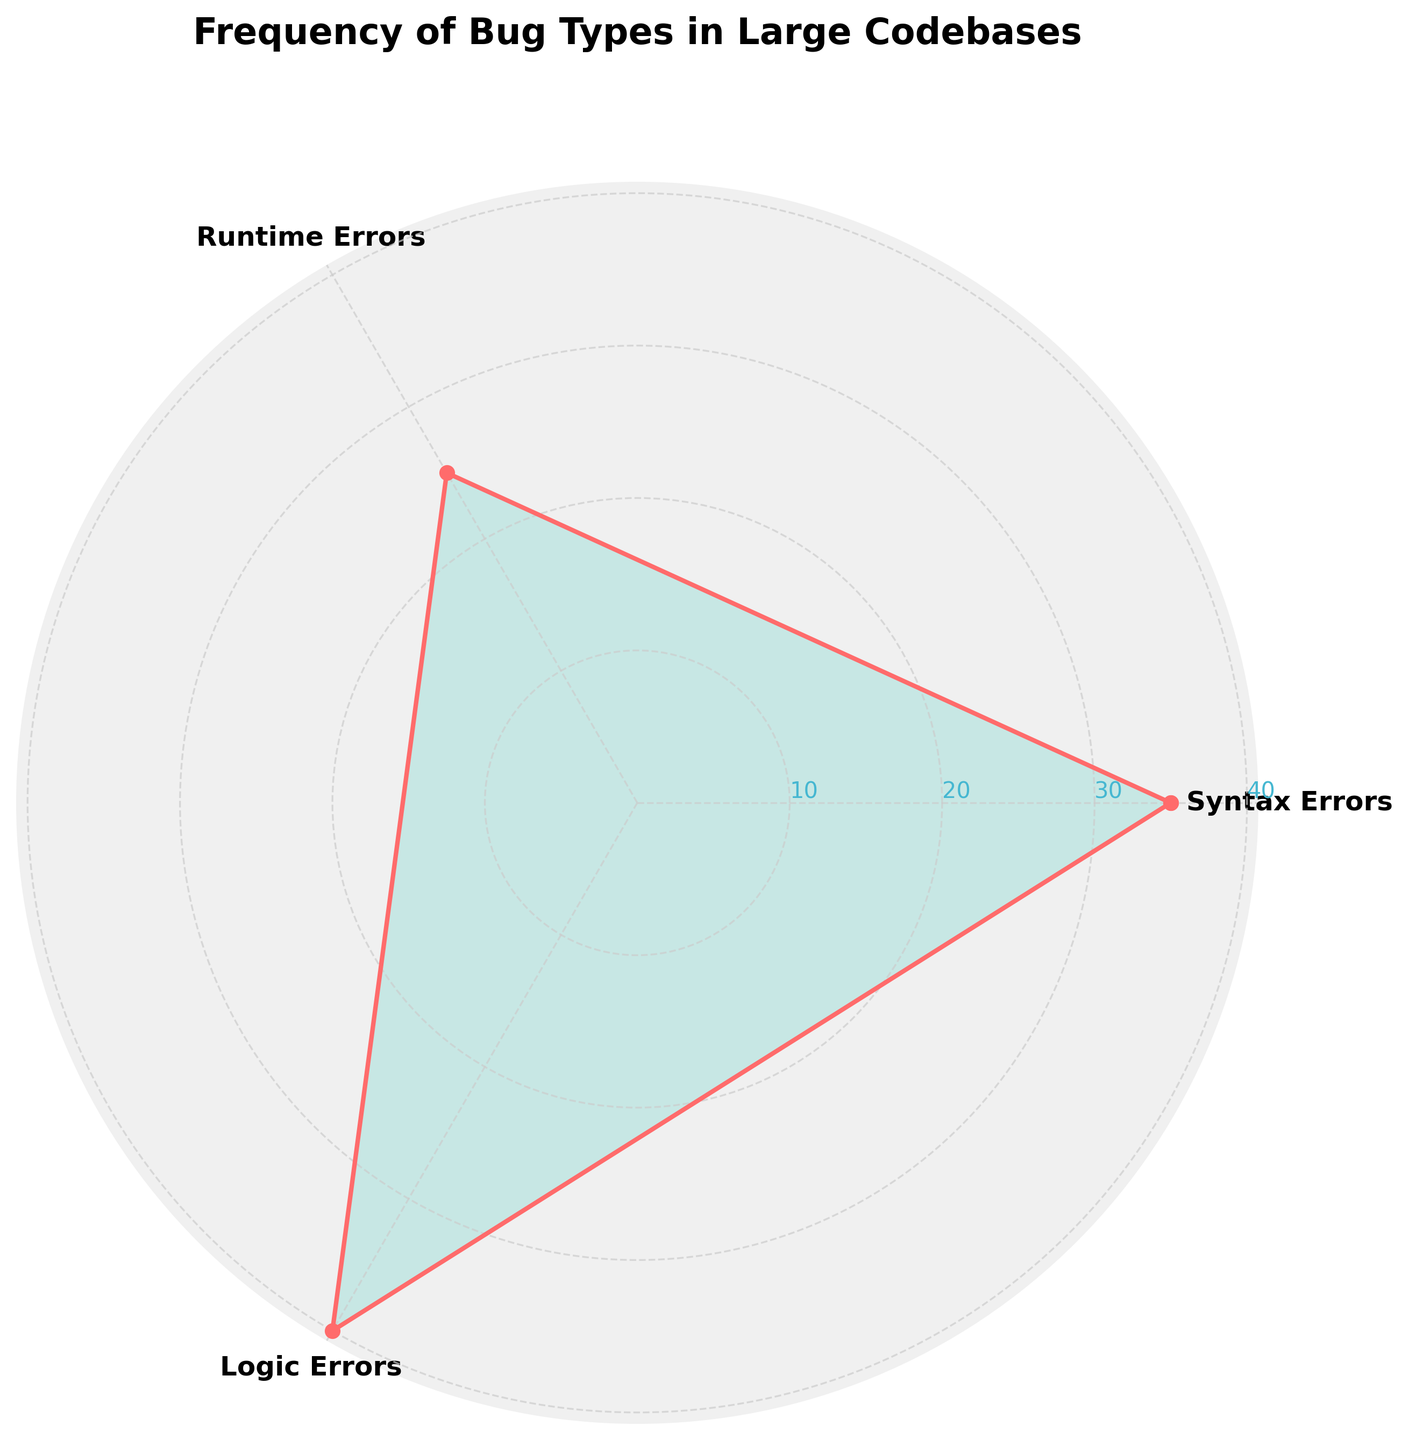Which bug type has the highest frequency? By examining the rose chart, the tallest segment represents the bug type with the highest frequency. The segment for Logic Errors is the tallest, indicating it has the highest frequency.
Answer: Logic Errors What is the total frequency of all bug types combined? To find the total frequency, sum the frequencies of each bug type: 35 (Syntax Errors) + 25 (Runtime Errors) + 40 (Logic Errors). This equals 100.
Answer: 100 How much higher is the frequency of Logic Errors compared to Runtime Errors? Subtract the frequency of Runtime Errors from the frequency of Logic Errors: 40 (Logic Errors) - 25 (Runtime Errors) = 15.
Answer: 15 Which bug type has the lowest frequency? The shortest segment in the rose chart represents the bug type with the lowest frequency. The segment for Runtime Errors is the shortest, indicating it has the lowest frequency.
Answer: Runtime Errors What is the average frequency of the three bug types? To find the average, add the frequencies and divide by the number of bug types: (35 + 25 + 40) / 3 = 100 / 3 ≈ 33.33.
Answer: 33.33 How does the frequency of Syntax Errors compare to the combined frequency of Runtime and Logic Errors? First, add the frequencies of Runtime and Logic Errors: 25 (Runtime Errors) + 40 (Logic Errors) = 65. Syntax Errors have a frequency of 35. Since 35 is less than 65, Syntax Errors are less frequent than the combined frequency of the other two types.
Answer: Less frequent By what percentage is the frequency of Logic Errors higher than that of Syntax Errors? First, find the difference in frequency: 40 (Logic Errors) - 35 (Syntax Errors) = 5. Then calculate the percentage relative to Syntax Errors: (5 / 35) * 100 ≈ 14.29%.
Answer: 14.29% What percentage of the total frequency is made up by Runtime Errors? First, find the total frequency: 100. Then calculate the percentage of Runtime Errors: (25 / 100) * 100 = 25%.
Answer: 25% If another bug type with a frequency of 30 bugs was added, what would the new average frequency be? First, find the new total frequency: 100 (original total) + 30 = 130. Then calculate the new average: 130 / 4 = 32.5.
Answer: 32.5 